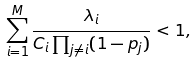<formula> <loc_0><loc_0><loc_500><loc_500>\sum _ { i = 1 } ^ { M } \frac { \lambda _ { i } } { C _ { i } \prod _ { j \neq i } ( 1 - p _ { j } ) } < 1 ,</formula> 